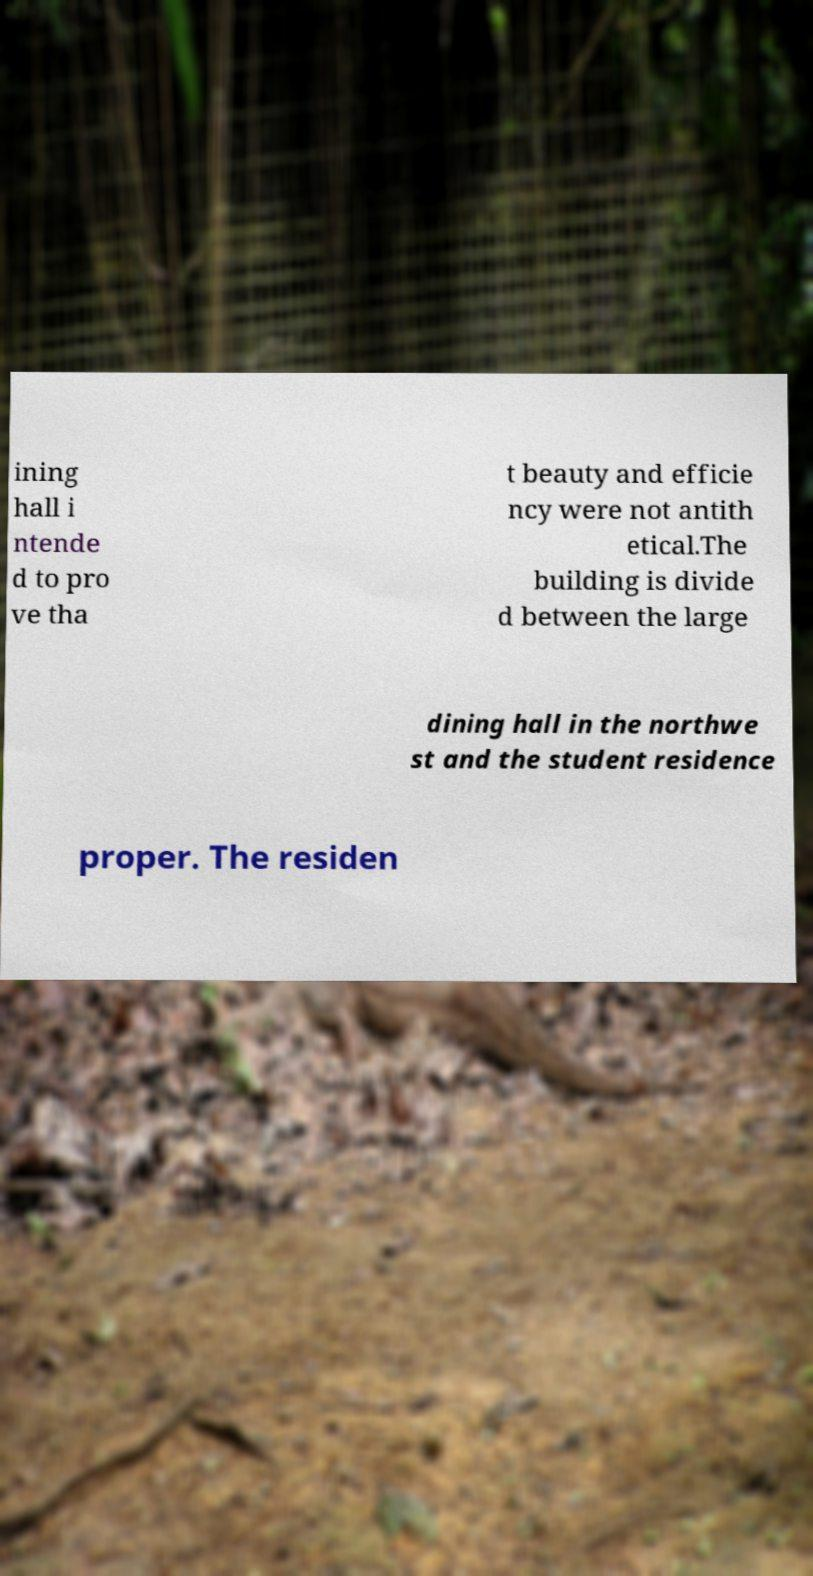Please read and relay the text visible in this image. What does it say? ining hall i ntende d to pro ve tha t beauty and efficie ncy were not antith etical.The building is divide d between the large dining hall in the northwe st and the student residence proper. The residen 